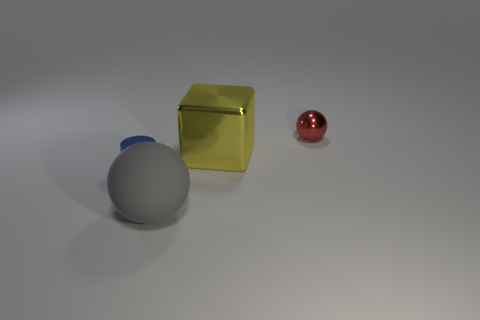If you had to guess, what material do you think each object is made of? Based on their appearances, I would guess the hemisphere is made of a matte plastic with a blue coloration, the cube seems to be a metallic gold suggesting it could be a painted metal or a metallic plastic, and the small sphere has a reflective surface, resembling either polished metal or a shiny plastic. What could be the purpose of these objects being arranged like this? The arrangement looks deliberate and could be for a number of purposes, such as a visual composition exercise, a demonstration of object positioning, or a still life setup for photography or rendering practice, intending to showcase different shapes, materials, and colors. 